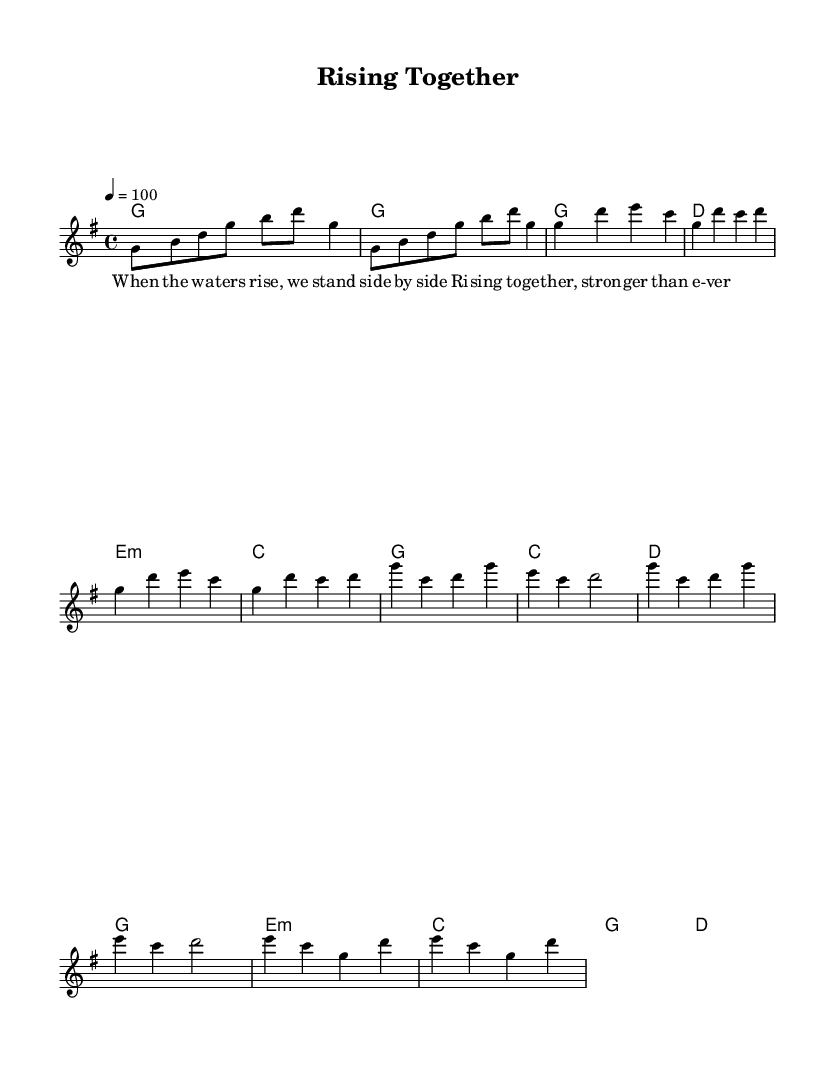What is the key signature of this music? The key signature is G major, which has one sharp (F#). You can determine this by looking at the beginning of the staff where the key signature is indicated.
Answer: G major What is the time signature of this music? The time signature is 4/4. This can be identified at the beginning of the music where the numbers are displayed over the staff, indicating four beats per measure.
Answer: 4/4 What is the tempo marking for this piece? The tempo marking is 100 beats per minute. This is found next to the tempo indication (4=100), specifying the speed of the piece.
Answer: 100 How many measures are in the chorus? There are four measures in the chorus. To find this, count the measures in the section labeled as the chorus based on the music notation.
Answer: 4 What is the mood expressed through the lyrics? The mood expressed is uplifting and supportive, as indicated by words like "Rising together, stronger than ever". This reflects feelings of community solidarity.
Answer: Uplifting What is the relationship between the verses and the chorus in terms of melody? The melody in the chorus has a more anthemic and soaring quality compared to the verses, emphasizing a sense of unity. This observation can be made by comparing the melodic structure and rhythmic pacing of the lyrics.
Answer: Anthemic Which chord follows the second verse line? The chord that follows the second verse line is C major. This can be verified by looking at the chord symbols indicated above the melody during that section.
Answer: C 